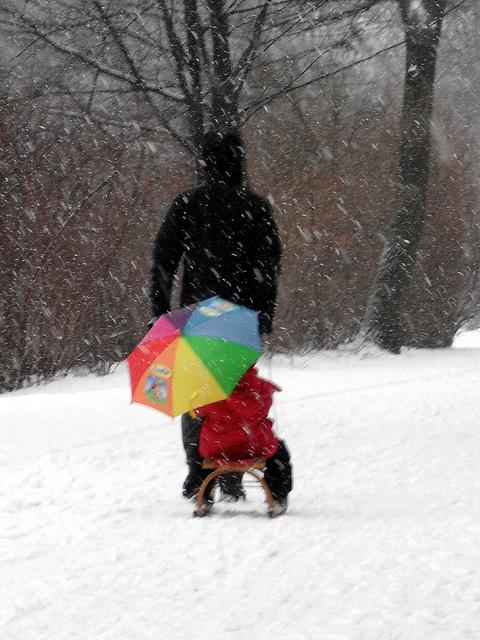In which location might this umbrella be appropriate? Please explain your reasoning. pride parade. The location is the pride parade. 